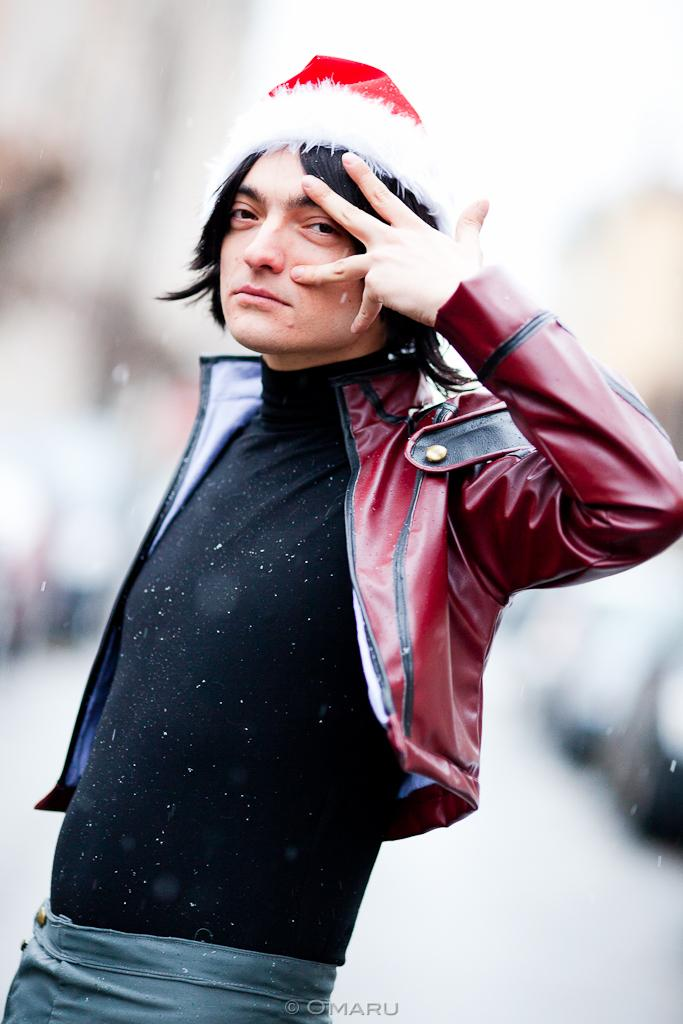What is the main subject of the image? There is a man in the image. Where is the man positioned in the image? The man is standing in the center of the image. Can you describe the background of the image? The background of the image is blurred. What type of dog can be seen playing with a hook in the image? There is no dog or hook present in the image; it features a man standing in the center with a blurred background. 